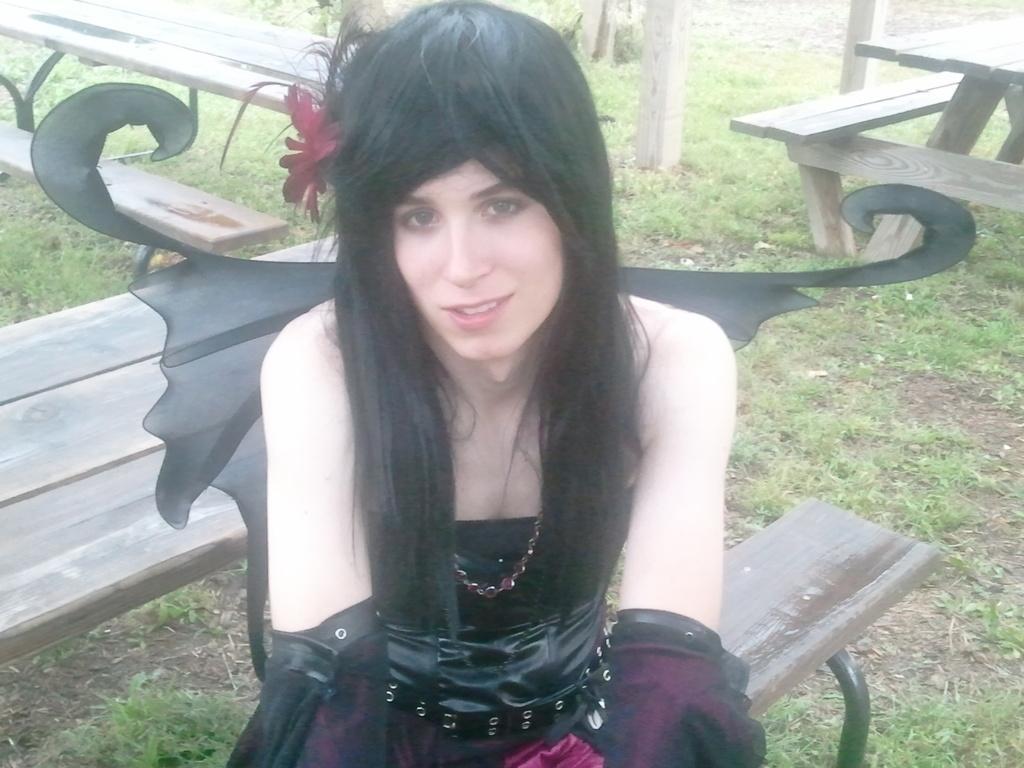Could you give a brief overview of what you see in this image? In the image we can see that a woman is sitting on bench. She is wearing a black and pink color clothes. There is a flower, grass and a pole. 